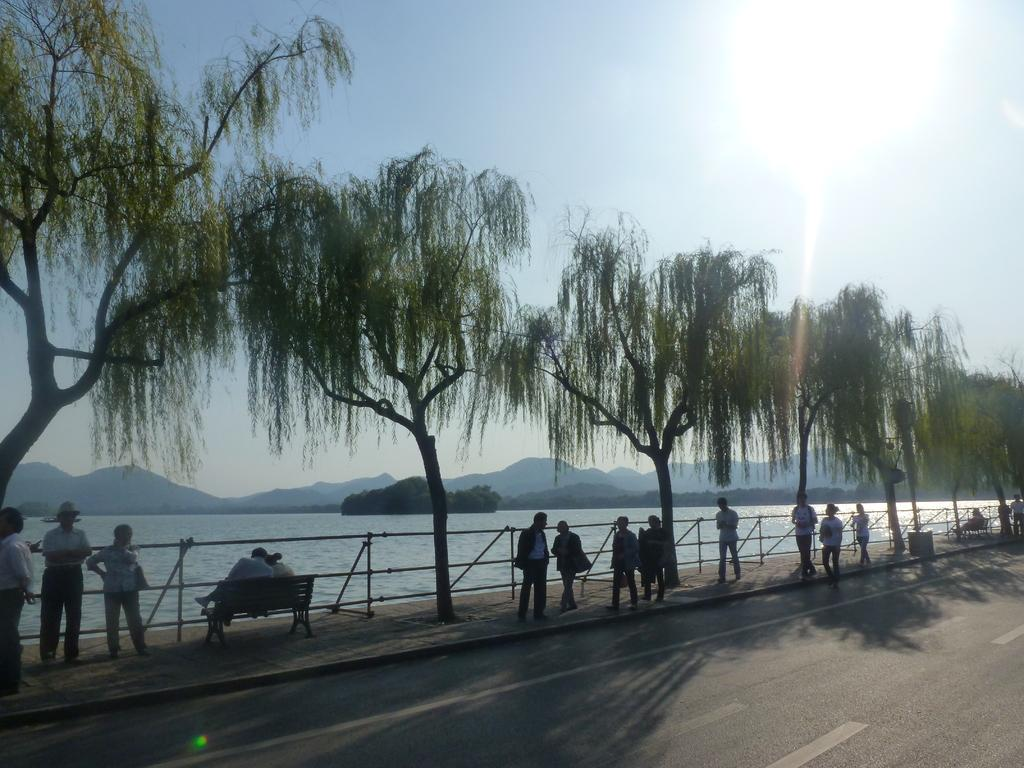What can be seen on the footpath in the image? There is a group of persons on the persons on the footpath in the image. What is located at the bottom of the image? There is a road at the bottom of the image. What type of landscape can be seen in the background of the image? There are hills and water visible in the background of the image. What is visible in the sky in the image? The sky is visible in the background of the image. What type of pencil is being used for breakfast in the image? There is no pencil or breakfast present in the image. What time of day does the dinner scene take place in the image? There is no dinner scene present in the image. 